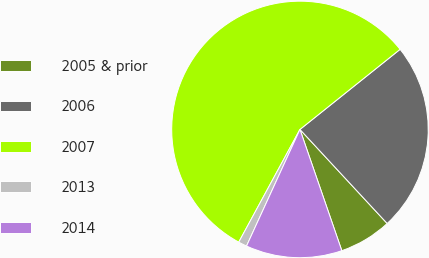Convert chart to OTSL. <chart><loc_0><loc_0><loc_500><loc_500><pie_chart><fcel>2005 & prior<fcel>2006<fcel>2007<fcel>2013<fcel>2014<nl><fcel>6.61%<fcel>23.84%<fcel>56.34%<fcel>1.08%<fcel>12.13%<nl></chart> 